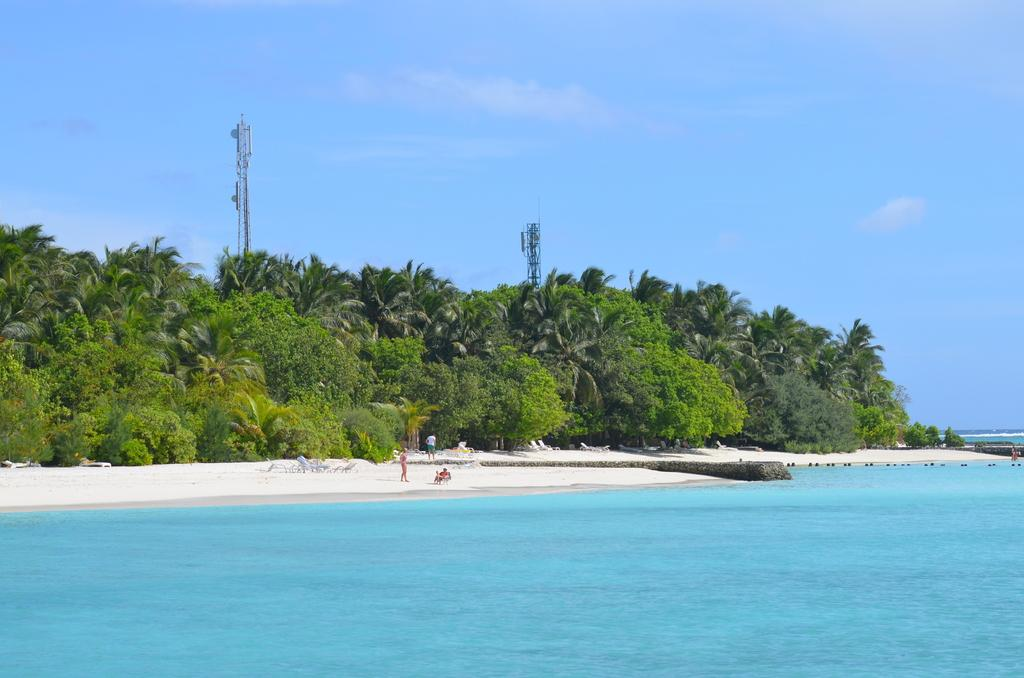What structures are located in the center of the image? There are buildings and towers in the center of the image. What can be seen at the bottom of the image? There is water visible at the bottom of the image. Who or what is present in the image? People are present in the image. What is visible at the top of the image? The sky is visible at the top of the image. Can you see a boat floating in the water in the image? There is no boat visible in the water in the image. Is there a bottle of water being held by a person in the image? There is no bottle of water present in the image. 